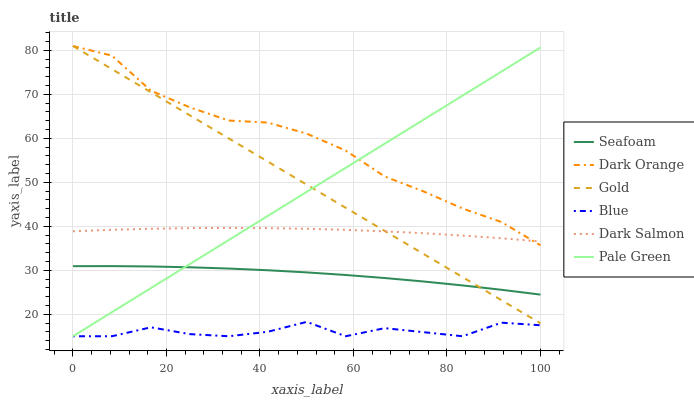Does Blue have the minimum area under the curve?
Answer yes or no. Yes. Does Dark Orange have the maximum area under the curve?
Answer yes or no. Yes. Does Gold have the minimum area under the curve?
Answer yes or no. No. Does Gold have the maximum area under the curve?
Answer yes or no. No. Is Pale Green the smoothest?
Answer yes or no. Yes. Is Blue the roughest?
Answer yes or no. Yes. Is Dark Orange the smoothest?
Answer yes or no. No. Is Dark Orange the roughest?
Answer yes or no. No. Does Blue have the lowest value?
Answer yes or no. Yes. Does Dark Orange have the lowest value?
Answer yes or no. No. Does Gold have the highest value?
Answer yes or no. Yes. Does Seafoam have the highest value?
Answer yes or no. No. Is Blue less than Dark Salmon?
Answer yes or no. Yes. Is Dark Orange greater than Blue?
Answer yes or no. Yes. Does Pale Green intersect Blue?
Answer yes or no. Yes. Is Pale Green less than Blue?
Answer yes or no. No. Is Pale Green greater than Blue?
Answer yes or no. No. Does Blue intersect Dark Salmon?
Answer yes or no. No. 